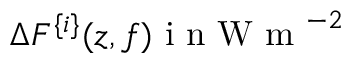<formula> <loc_0><loc_0><loc_500><loc_500>\Delta F ^ { \{ i \} } ( z , f ) i n W m ^ { - 2 }</formula> 